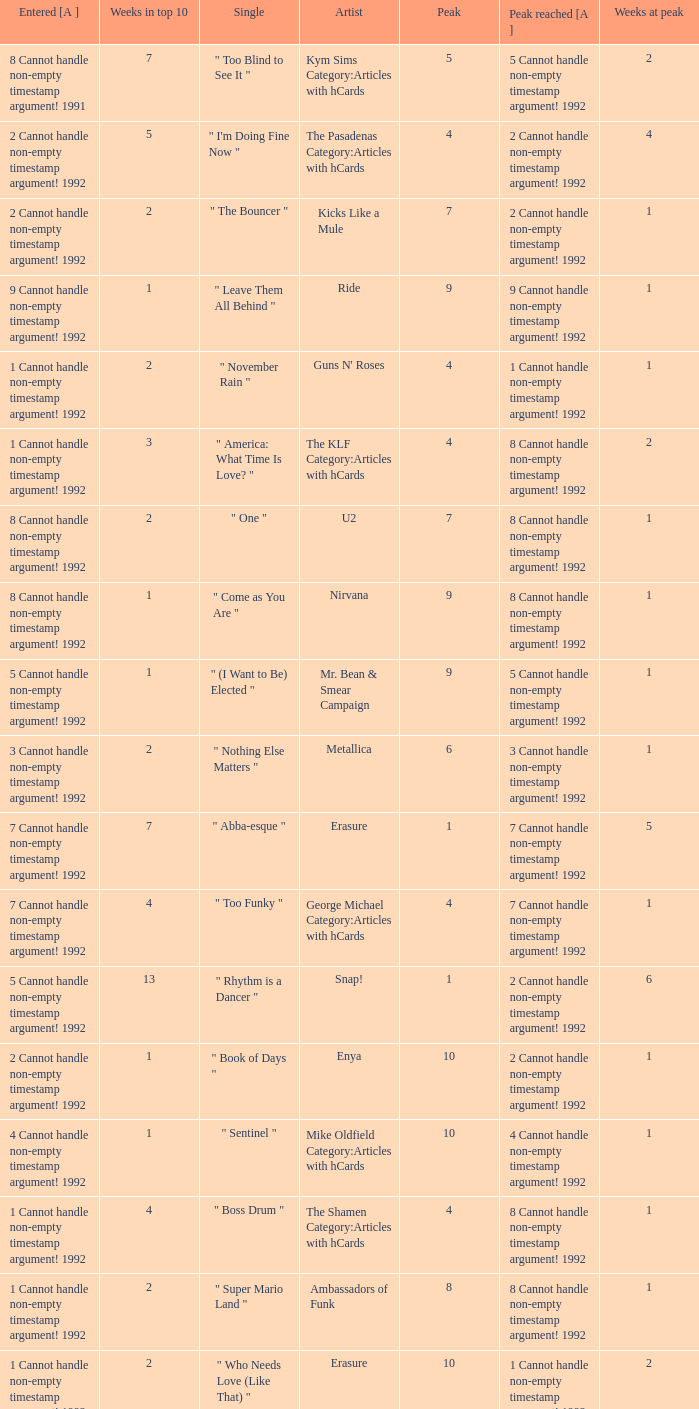If the peak is 9, how many weeks was it in the top 10? 1.0. 